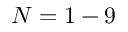Convert formula to latex. <formula><loc_0><loc_0><loc_500><loc_500>N = 1 - 9</formula> 